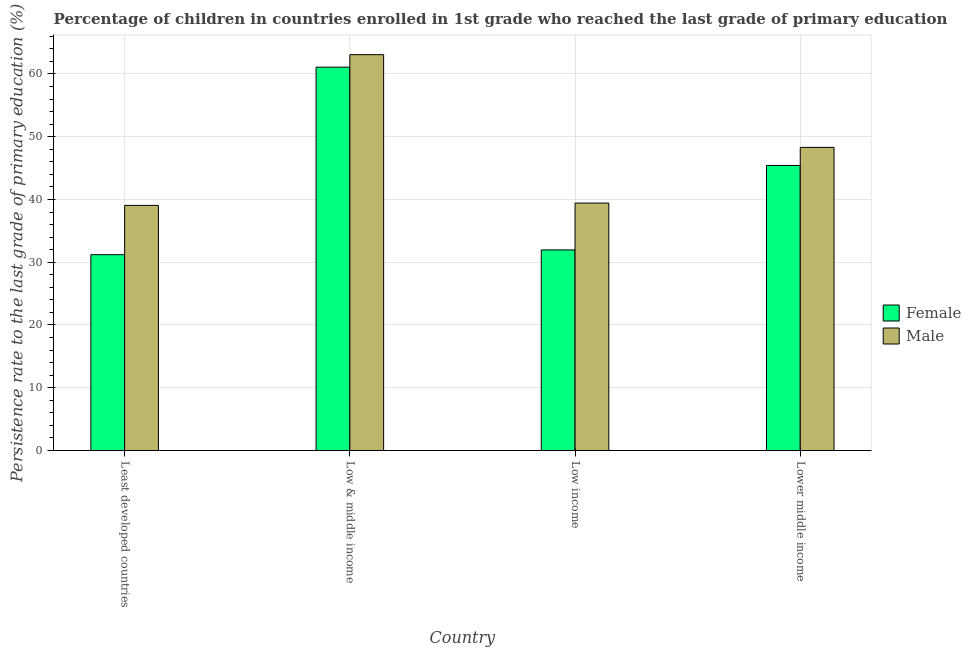Are the number of bars on each tick of the X-axis equal?
Provide a short and direct response. Yes. What is the label of the 2nd group of bars from the left?
Offer a terse response. Low & middle income. In how many cases, is the number of bars for a given country not equal to the number of legend labels?
Keep it short and to the point. 0. What is the persistence rate of female students in Lower middle income?
Your answer should be very brief. 45.42. Across all countries, what is the maximum persistence rate of male students?
Make the answer very short. 63.08. Across all countries, what is the minimum persistence rate of male students?
Keep it short and to the point. 39.06. In which country was the persistence rate of female students minimum?
Offer a terse response. Least developed countries. What is the total persistence rate of male students in the graph?
Offer a terse response. 189.88. What is the difference between the persistence rate of female students in Least developed countries and that in Low & middle income?
Offer a terse response. -29.89. What is the difference between the persistence rate of male students in Lower middle income and the persistence rate of female students in Low & middle income?
Offer a terse response. -12.79. What is the average persistence rate of female students per country?
Give a very brief answer. 42.42. What is the difference between the persistence rate of male students and persistence rate of female students in Least developed countries?
Offer a terse response. 7.86. In how many countries, is the persistence rate of male students greater than 2 %?
Make the answer very short. 4. What is the ratio of the persistence rate of male students in Least developed countries to that in Low & middle income?
Make the answer very short. 0.62. What is the difference between the highest and the second highest persistence rate of male students?
Offer a very short reply. 14.78. What is the difference between the highest and the lowest persistence rate of male students?
Offer a terse response. 24.02. Are all the bars in the graph horizontal?
Make the answer very short. No. What is the difference between two consecutive major ticks on the Y-axis?
Offer a very short reply. 10. Are the values on the major ticks of Y-axis written in scientific E-notation?
Give a very brief answer. No. Does the graph contain grids?
Ensure brevity in your answer.  Yes. How many legend labels are there?
Give a very brief answer. 2. How are the legend labels stacked?
Provide a succinct answer. Vertical. What is the title of the graph?
Offer a terse response. Percentage of children in countries enrolled in 1st grade who reached the last grade of primary education. What is the label or title of the X-axis?
Offer a terse response. Country. What is the label or title of the Y-axis?
Keep it short and to the point. Persistence rate to the last grade of primary education (%). What is the Persistence rate to the last grade of primary education (%) of Female in Least developed countries?
Keep it short and to the point. 31.2. What is the Persistence rate to the last grade of primary education (%) in Male in Least developed countries?
Give a very brief answer. 39.06. What is the Persistence rate to the last grade of primary education (%) of Female in Low & middle income?
Your answer should be compact. 61.09. What is the Persistence rate to the last grade of primary education (%) of Male in Low & middle income?
Your response must be concise. 63.08. What is the Persistence rate to the last grade of primary education (%) of Female in Low income?
Keep it short and to the point. 31.96. What is the Persistence rate to the last grade of primary education (%) of Male in Low income?
Give a very brief answer. 39.43. What is the Persistence rate to the last grade of primary education (%) of Female in Lower middle income?
Provide a succinct answer. 45.42. What is the Persistence rate to the last grade of primary education (%) of Male in Lower middle income?
Make the answer very short. 48.3. Across all countries, what is the maximum Persistence rate to the last grade of primary education (%) of Female?
Give a very brief answer. 61.09. Across all countries, what is the maximum Persistence rate to the last grade of primary education (%) in Male?
Your answer should be very brief. 63.08. Across all countries, what is the minimum Persistence rate to the last grade of primary education (%) of Female?
Provide a short and direct response. 31.2. Across all countries, what is the minimum Persistence rate to the last grade of primary education (%) of Male?
Give a very brief answer. 39.06. What is the total Persistence rate to the last grade of primary education (%) in Female in the graph?
Your answer should be compact. 169.68. What is the total Persistence rate to the last grade of primary education (%) in Male in the graph?
Keep it short and to the point. 189.88. What is the difference between the Persistence rate to the last grade of primary education (%) of Female in Least developed countries and that in Low & middle income?
Make the answer very short. -29.89. What is the difference between the Persistence rate to the last grade of primary education (%) in Male in Least developed countries and that in Low & middle income?
Provide a short and direct response. -24.02. What is the difference between the Persistence rate to the last grade of primary education (%) in Female in Least developed countries and that in Low income?
Give a very brief answer. -0.76. What is the difference between the Persistence rate to the last grade of primary education (%) of Male in Least developed countries and that in Low income?
Provide a succinct answer. -0.37. What is the difference between the Persistence rate to the last grade of primary education (%) of Female in Least developed countries and that in Lower middle income?
Your answer should be very brief. -14.22. What is the difference between the Persistence rate to the last grade of primary education (%) of Male in Least developed countries and that in Lower middle income?
Keep it short and to the point. -9.24. What is the difference between the Persistence rate to the last grade of primary education (%) of Female in Low & middle income and that in Low income?
Give a very brief answer. 29.13. What is the difference between the Persistence rate to the last grade of primary education (%) of Male in Low & middle income and that in Low income?
Keep it short and to the point. 23.65. What is the difference between the Persistence rate to the last grade of primary education (%) in Female in Low & middle income and that in Lower middle income?
Ensure brevity in your answer.  15.67. What is the difference between the Persistence rate to the last grade of primary education (%) in Male in Low & middle income and that in Lower middle income?
Your answer should be very brief. 14.78. What is the difference between the Persistence rate to the last grade of primary education (%) of Female in Low income and that in Lower middle income?
Offer a terse response. -13.46. What is the difference between the Persistence rate to the last grade of primary education (%) in Male in Low income and that in Lower middle income?
Your answer should be very brief. -8.87. What is the difference between the Persistence rate to the last grade of primary education (%) in Female in Least developed countries and the Persistence rate to the last grade of primary education (%) in Male in Low & middle income?
Keep it short and to the point. -31.88. What is the difference between the Persistence rate to the last grade of primary education (%) in Female in Least developed countries and the Persistence rate to the last grade of primary education (%) in Male in Low income?
Keep it short and to the point. -8.23. What is the difference between the Persistence rate to the last grade of primary education (%) of Female in Least developed countries and the Persistence rate to the last grade of primary education (%) of Male in Lower middle income?
Provide a succinct answer. -17.1. What is the difference between the Persistence rate to the last grade of primary education (%) in Female in Low & middle income and the Persistence rate to the last grade of primary education (%) in Male in Low income?
Keep it short and to the point. 21.66. What is the difference between the Persistence rate to the last grade of primary education (%) of Female in Low & middle income and the Persistence rate to the last grade of primary education (%) of Male in Lower middle income?
Your response must be concise. 12.79. What is the difference between the Persistence rate to the last grade of primary education (%) in Female in Low income and the Persistence rate to the last grade of primary education (%) in Male in Lower middle income?
Provide a short and direct response. -16.34. What is the average Persistence rate to the last grade of primary education (%) in Female per country?
Your answer should be compact. 42.42. What is the average Persistence rate to the last grade of primary education (%) of Male per country?
Your answer should be compact. 47.47. What is the difference between the Persistence rate to the last grade of primary education (%) of Female and Persistence rate to the last grade of primary education (%) of Male in Least developed countries?
Make the answer very short. -7.86. What is the difference between the Persistence rate to the last grade of primary education (%) in Female and Persistence rate to the last grade of primary education (%) in Male in Low & middle income?
Offer a terse response. -1.99. What is the difference between the Persistence rate to the last grade of primary education (%) of Female and Persistence rate to the last grade of primary education (%) of Male in Low income?
Your response must be concise. -7.47. What is the difference between the Persistence rate to the last grade of primary education (%) in Female and Persistence rate to the last grade of primary education (%) in Male in Lower middle income?
Your answer should be compact. -2.88. What is the ratio of the Persistence rate to the last grade of primary education (%) of Female in Least developed countries to that in Low & middle income?
Your answer should be compact. 0.51. What is the ratio of the Persistence rate to the last grade of primary education (%) of Male in Least developed countries to that in Low & middle income?
Ensure brevity in your answer.  0.62. What is the ratio of the Persistence rate to the last grade of primary education (%) in Female in Least developed countries to that in Low income?
Offer a terse response. 0.98. What is the ratio of the Persistence rate to the last grade of primary education (%) of Male in Least developed countries to that in Low income?
Provide a succinct answer. 0.99. What is the ratio of the Persistence rate to the last grade of primary education (%) of Female in Least developed countries to that in Lower middle income?
Keep it short and to the point. 0.69. What is the ratio of the Persistence rate to the last grade of primary education (%) of Male in Least developed countries to that in Lower middle income?
Your answer should be very brief. 0.81. What is the ratio of the Persistence rate to the last grade of primary education (%) in Female in Low & middle income to that in Low income?
Provide a succinct answer. 1.91. What is the ratio of the Persistence rate to the last grade of primary education (%) in Male in Low & middle income to that in Low income?
Your answer should be compact. 1.6. What is the ratio of the Persistence rate to the last grade of primary education (%) of Female in Low & middle income to that in Lower middle income?
Give a very brief answer. 1.34. What is the ratio of the Persistence rate to the last grade of primary education (%) of Male in Low & middle income to that in Lower middle income?
Give a very brief answer. 1.31. What is the ratio of the Persistence rate to the last grade of primary education (%) of Female in Low income to that in Lower middle income?
Give a very brief answer. 0.7. What is the ratio of the Persistence rate to the last grade of primary education (%) in Male in Low income to that in Lower middle income?
Offer a very short reply. 0.82. What is the difference between the highest and the second highest Persistence rate to the last grade of primary education (%) of Female?
Offer a very short reply. 15.67. What is the difference between the highest and the second highest Persistence rate to the last grade of primary education (%) in Male?
Provide a short and direct response. 14.78. What is the difference between the highest and the lowest Persistence rate to the last grade of primary education (%) of Female?
Provide a succinct answer. 29.89. What is the difference between the highest and the lowest Persistence rate to the last grade of primary education (%) in Male?
Your answer should be very brief. 24.02. 